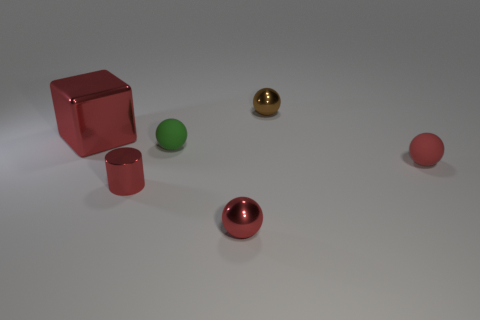There is a metallic ball in front of the large red cube; is its color the same as the small shiny thing left of the tiny green matte object?
Your answer should be compact. Yes. Are there any other things that are the same color as the metallic block?
Provide a succinct answer. Yes. What is the tiny cylinder made of?
Make the answer very short. Metal. What number of brown objects are the same size as the green rubber ball?
Ensure brevity in your answer.  1. What is the shape of the big thing that is the same color as the small metallic cylinder?
Provide a short and direct response. Cube. Are there any small metal things that have the same shape as the small red rubber object?
Offer a very short reply. Yes. The rubber thing that is the same size as the red rubber sphere is what color?
Offer a terse response. Green. What color is the tiny shiny object behind the red object to the right of the tiny brown sphere?
Ensure brevity in your answer.  Brown. Do the metal ball that is in front of the large red object and the large metal object have the same color?
Offer a terse response. Yes. The small metal thing on the left side of the small matte sphere left of the sphere that is behind the big red object is what shape?
Offer a terse response. Cylinder. 